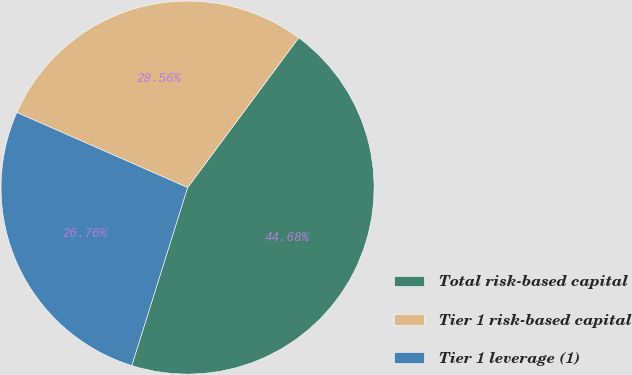Convert chart. <chart><loc_0><loc_0><loc_500><loc_500><pie_chart><fcel>Total risk-based capital<fcel>Tier 1 risk-based capital<fcel>Tier 1 leverage (1)<nl><fcel>44.68%<fcel>28.56%<fcel>26.76%<nl></chart> 